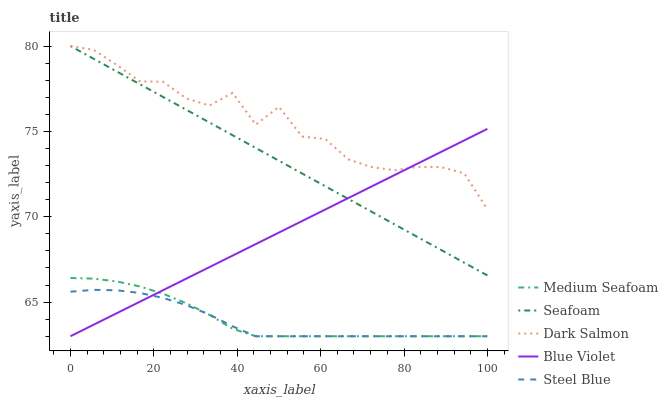Does Steel Blue have the minimum area under the curve?
Answer yes or no. Yes. Does Dark Salmon have the maximum area under the curve?
Answer yes or no. Yes. Does Medium Seafoam have the minimum area under the curve?
Answer yes or no. No. Does Medium Seafoam have the maximum area under the curve?
Answer yes or no. No. Is Seafoam the smoothest?
Answer yes or no. Yes. Is Dark Salmon the roughest?
Answer yes or no. Yes. Is Medium Seafoam the smoothest?
Answer yes or no. No. Is Medium Seafoam the roughest?
Answer yes or no. No. Does Steel Blue have the lowest value?
Answer yes or no. Yes. Does Dark Salmon have the lowest value?
Answer yes or no. No. Does Seafoam have the highest value?
Answer yes or no. Yes. Does Medium Seafoam have the highest value?
Answer yes or no. No. Is Medium Seafoam less than Dark Salmon?
Answer yes or no. Yes. Is Seafoam greater than Medium Seafoam?
Answer yes or no. Yes. Does Blue Violet intersect Steel Blue?
Answer yes or no. Yes. Is Blue Violet less than Steel Blue?
Answer yes or no. No. Is Blue Violet greater than Steel Blue?
Answer yes or no. No. Does Medium Seafoam intersect Dark Salmon?
Answer yes or no. No. 